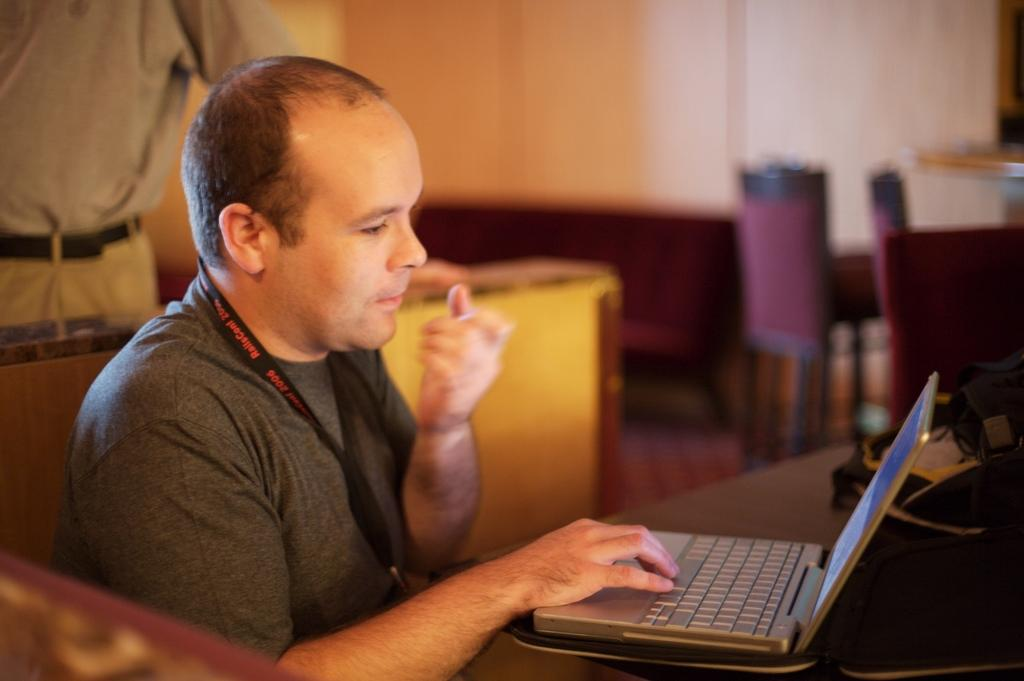What is the man in the image doing? The man is sitting and using a laptop in the image. Can you describe the person standing in the image? There is a person standing on the left side of the image. What type of furniture is visible in the image? Chairs are visible in the image. What is the background of the image composed of? There is a wall in the image. What type of art is the fowl creating on the wall in the image? There is no fowl or art present in the image; it only features a man sitting, a person standing, chairs, and a wall. 